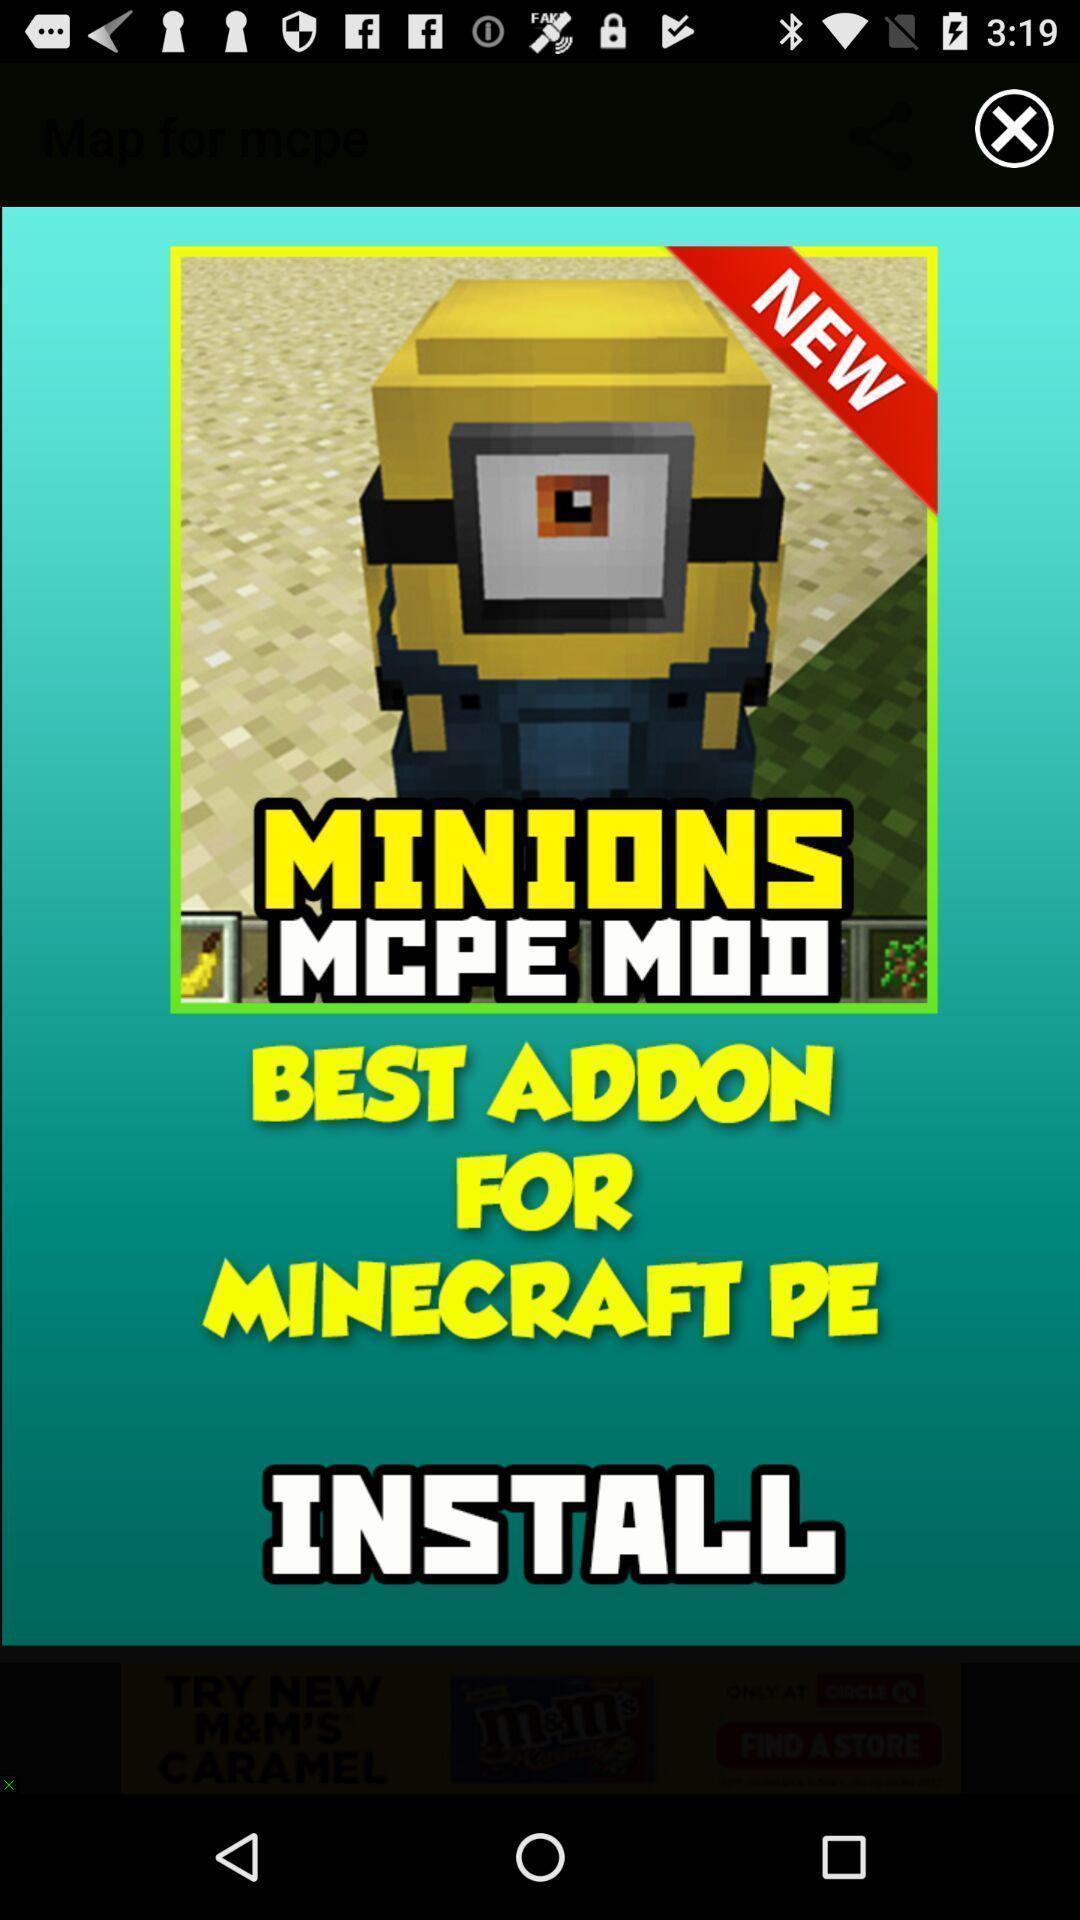Provide a description of this screenshot. Pop up ad displaying install game. 